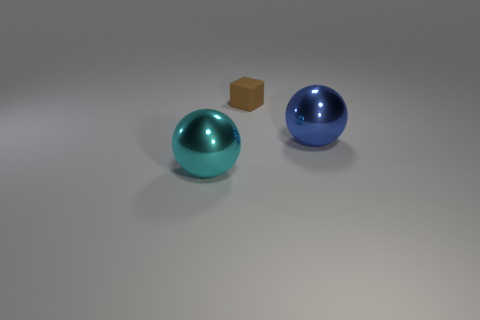Is there any indication of the scale or size of these objects? The image doesn't provide explicit indicators of scale, such as familiar objects for size comparison or a background with discernible depth cues. They could range from miniature desk ornaments to large, room-sized art installations. The drop shadow provides subtle clues about the proximity of the objects to the surface beneath them, suggesting they are relatively close together, but without additional context, one's interpretation of their size remains speculative. 